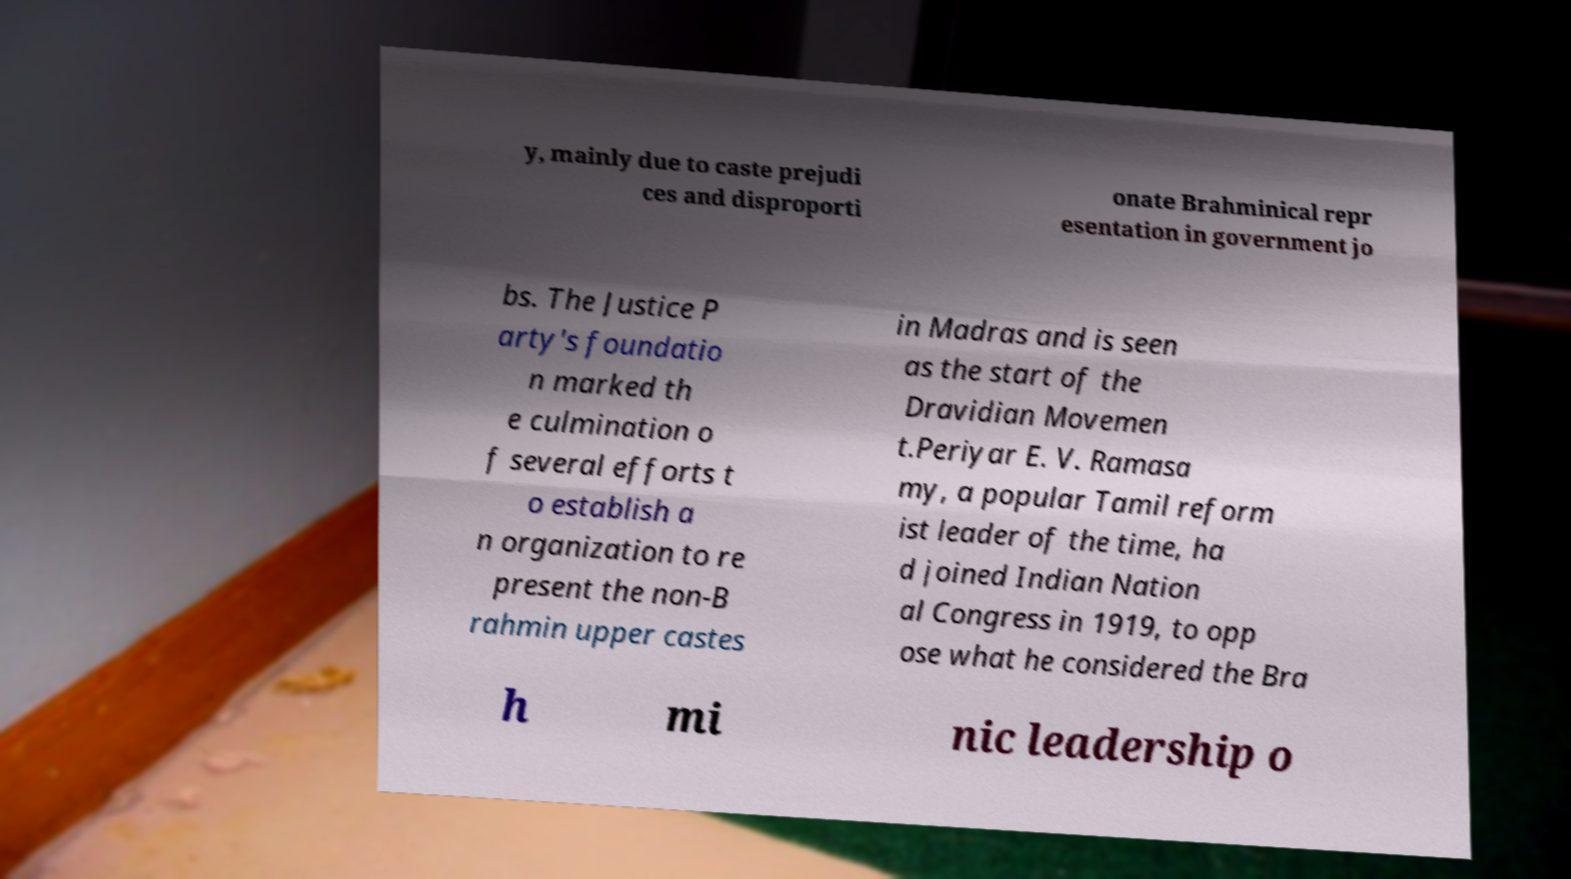Could you assist in decoding the text presented in this image and type it out clearly? y, mainly due to caste prejudi ces and disproporti onate Brahminical repr esentation in government jo bs. The Justice P arty's foundatio n marked th e culmination o f several efforts t o establish a n organization to re present the non-B rahmin upper castes in Madras and is seen as the start of the Dravidian Movemen t.Periyar E. V. Ramasa my, a popular Tamil reform ist leader of the time, ha d joined Indian Nation al Congress in 1919, to opp ose what he considered the Bra h mi nic leadership o 